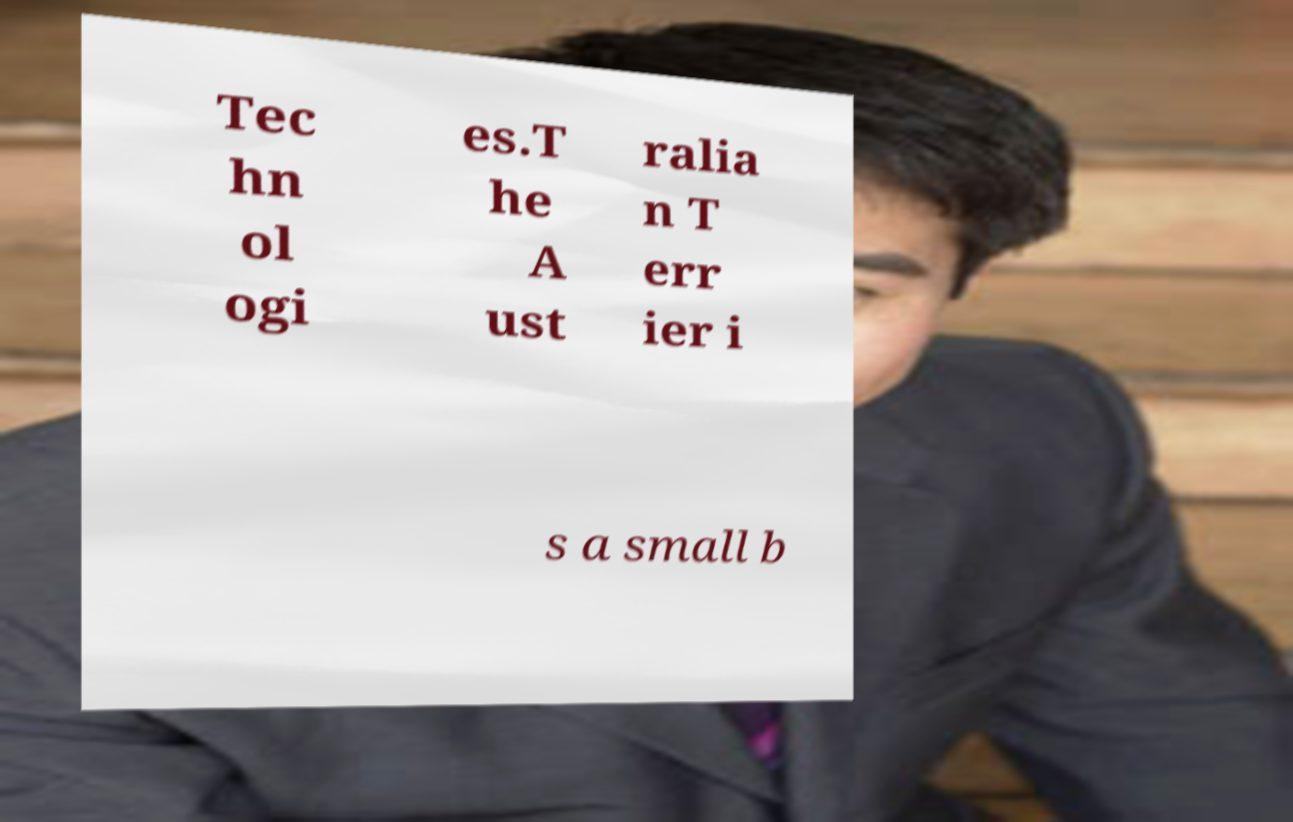I need the written content from this picture converted into text. Can you do that? Tec hn ol ogi es.T he A ust ralia n T err ier i s a small b 